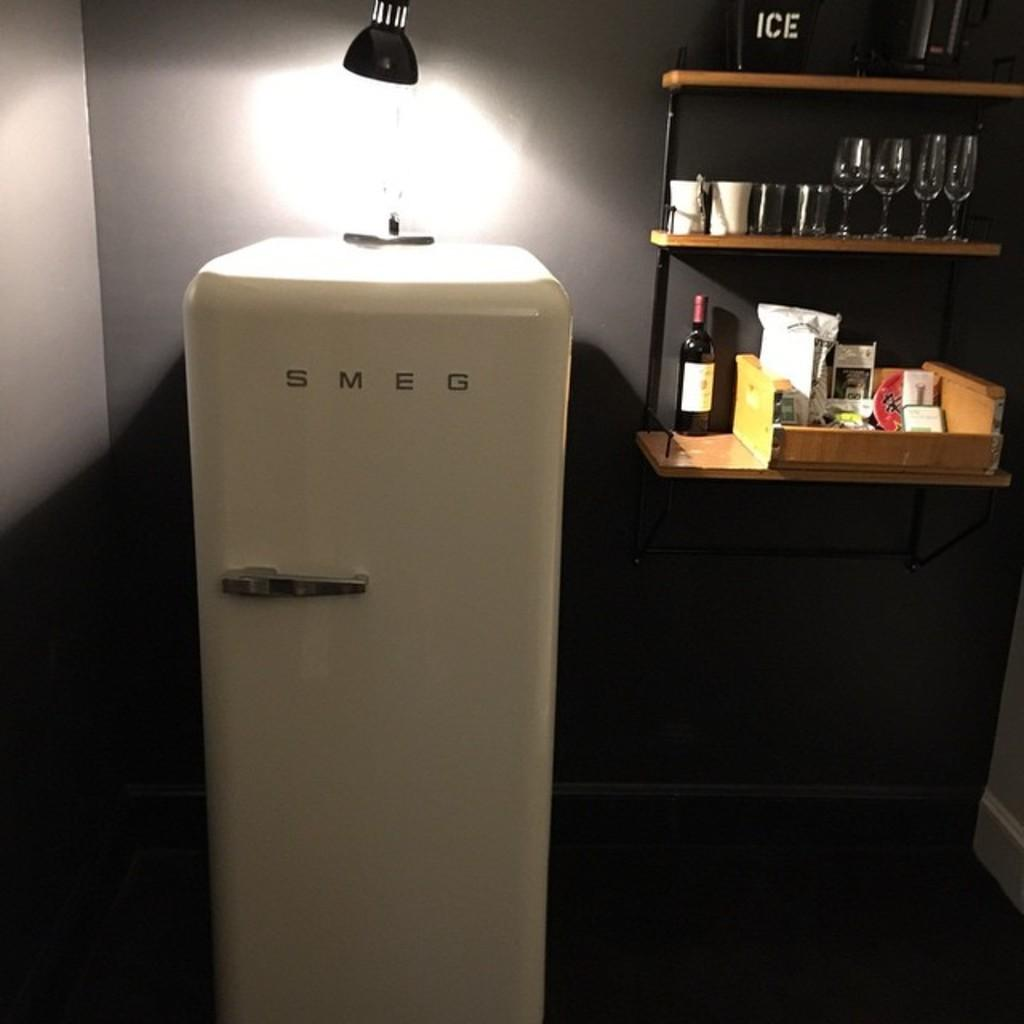Provide a one-sentence caption for the provided image. A small SMEG refrigerator sits next to a small bar with glasses. 